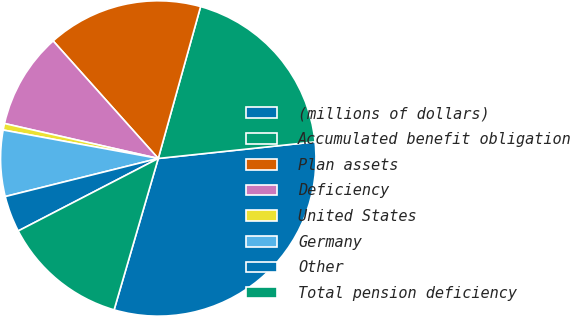Convert chart to OTSL. <chart><loc_0><loc_0><loc_500><loc_500><pie_chart><fcel>(millions of dollars)<fcel>Accumulated benefit obligation<fcel>Plan assets<fcel>Deficiency<fcel>United States<fcel>Germany<fcel>Other<fcel>Total pension deficiency<nl><fcel>31.2%<fcel>18.99%<fcel>15.94%<fcel>9.83%<fcel>0.67%<fcel>6.77%<fcel>3.72%<fcel>12.88%<nl></chart> 